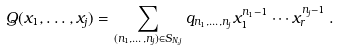Convert formula to latex. <formula><loc_0><loc_0><loc_500><loc_500>Q ( x _ { 1 } , \dots , x _ { j } ) = \sum _ { ( n _ { 1 } , \dots , n _ { j } ) \in S _ { N , j } } q _ { n _ { 1 } , \dots , n _ { j } } x _ { 1 } ^ { n _ { 1 } - 1 } \cdots x _ { r } ^ { n _ { j } - 1 } \, .</formula> 